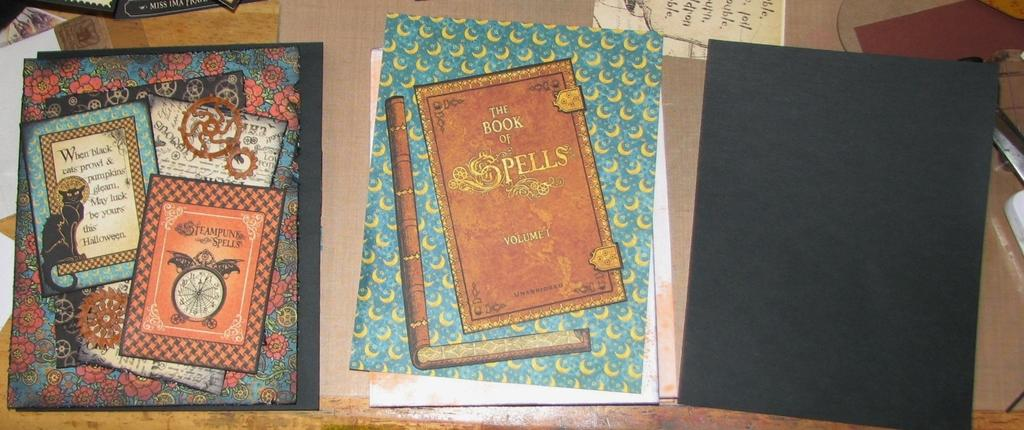<image>
Relay a brief, clear account of the picture shown. A book of spells is on a table with others. 